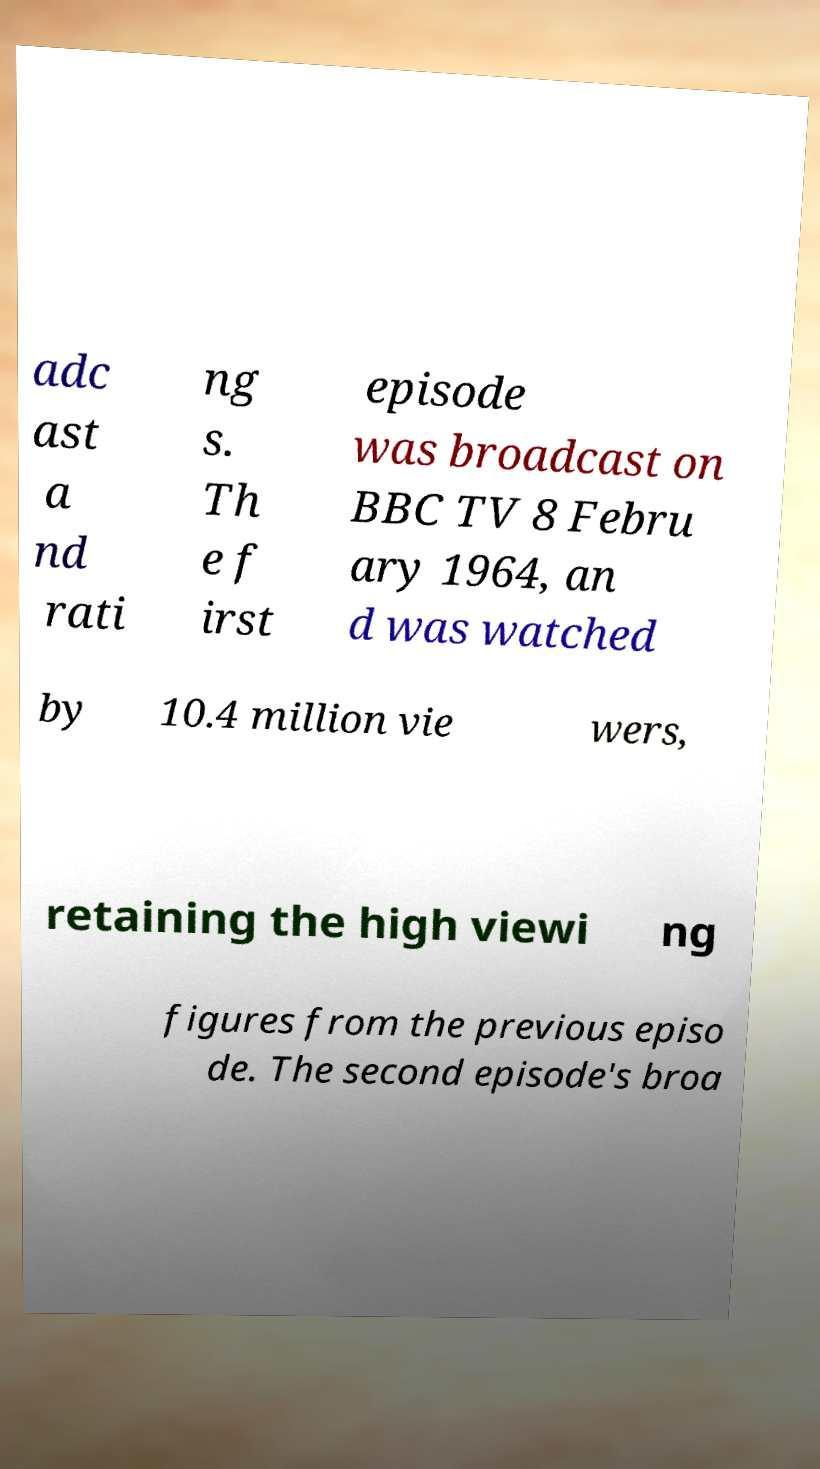Please identify and transcribe the text found in this image. adc ast a nd rati ng s. Th e f irst episode was broadcast on BBC TV 8 Febru ary 1964, an d was watched by 10.4 million vie wers, retaining the high viewi ng figures from the previous episo de. The second episode's broa 